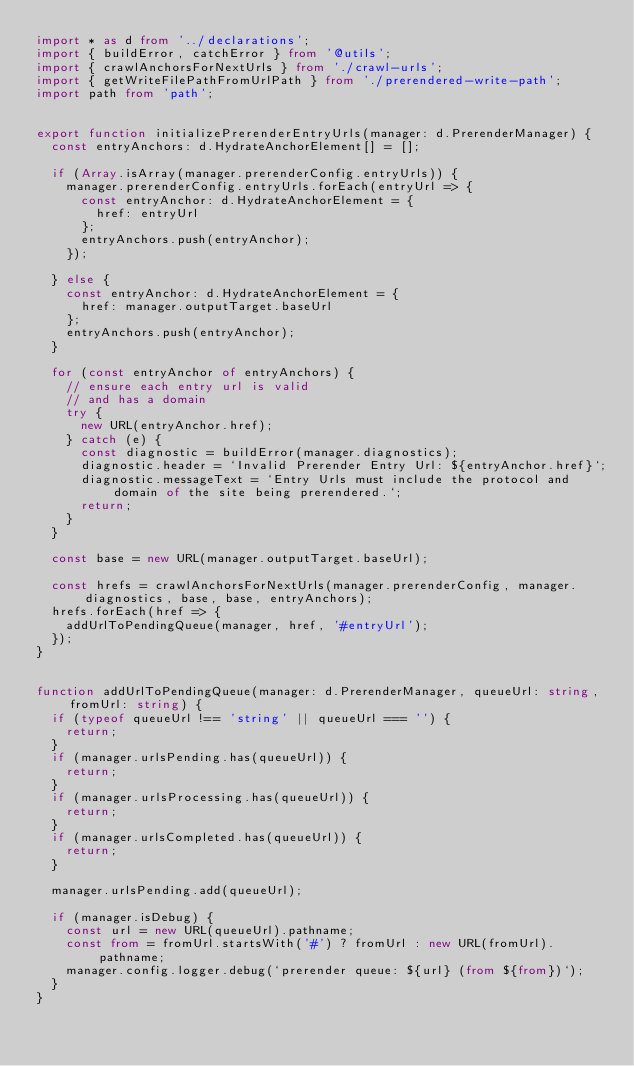Convert code to text. <code><loc_0><loc_0><loc_500><loc_500><_TypeScript_>import * as d from '../declarations';
import { buildError, catchError } from '@utils';
import { crawlAnchorsForNextUrls } from './crawl-urls';
import { getWriteFilePathFromUrlPath } from './prerendered-write-path';
import path from 'path';


export function initializePrerenderEntryUrls(manager: d.PrerenderManager) {
  const entryAnchors: d.HydrateAnchorElement[] = [];

  if (Array.isArray(manager.prerenderConfig.entryUrls)) {
    manager.prerenderConfig.entryUrls.forEach(entryUrl => {
      const entryAnchor: d.HydrateAnchorElement = {
        href: entryUrl
      };
      entryAnchors.push(entryAnchor);
    });

  } else {
    const entryAnchor: d.HydrateAnchorElement = {
      href: manager.outputTarget.baseUrl
    };
    entryAnchors.push(entryAnchor);
  }

  for (const entryAnchor of entryAnchors) {
    // ensure each entry url is valid
    // and has a domain
    try {
      new URL(entryAnchor.href);
    } catch (e) {
      const diagnostic = buildError(manager.diagnostics);
      diagnostic.header = `Invalid Prerender Entry Url: ${entryAnchor.href}`;
      diagnostic.messageText = `Entry Urls must include the protocol and domain of the site being prerendered.`;
      return;
    }
  }

  const base = new URL(manager.outputTarget.baseUrl);

  const hrefs = crawlAnchorsForNextUrls(manager.prerenderConfig, manager.diagnostics, base, base, entryAnchors);
  hrefs.forEach(href => {
    addUrlToPendingQueue(manager, href, '#entryUrl');
  });
}


function addUrlToPendingQueue(manager: d.PrerenderManager, queueUrl: string, fromUrl: string) {
  if (typeof queueUrl !== 'string' || queueUrl === '') {
    return;
  }
  if (manager.urlsPending.has(queueUrl)) {
    return;
  }
  if (manager.urlsProcessing.has(queueUrl)) {
    return;
  }
  if (manager.urlsCompleted.has(queueUrl)) {
    return;
  }

  manager.urlsPending.add(queueUrl);

  if (manager.isDebug) {
    const url = new URL(queueUrl).pathname;
    const from = fromUrl.startsWith('#') ? fromUrl : new URL(fromUrl).pathname;
    manager.config.logger.debug(`prerender queue: ${url} (from ${from})`);
  }
}

</code> 